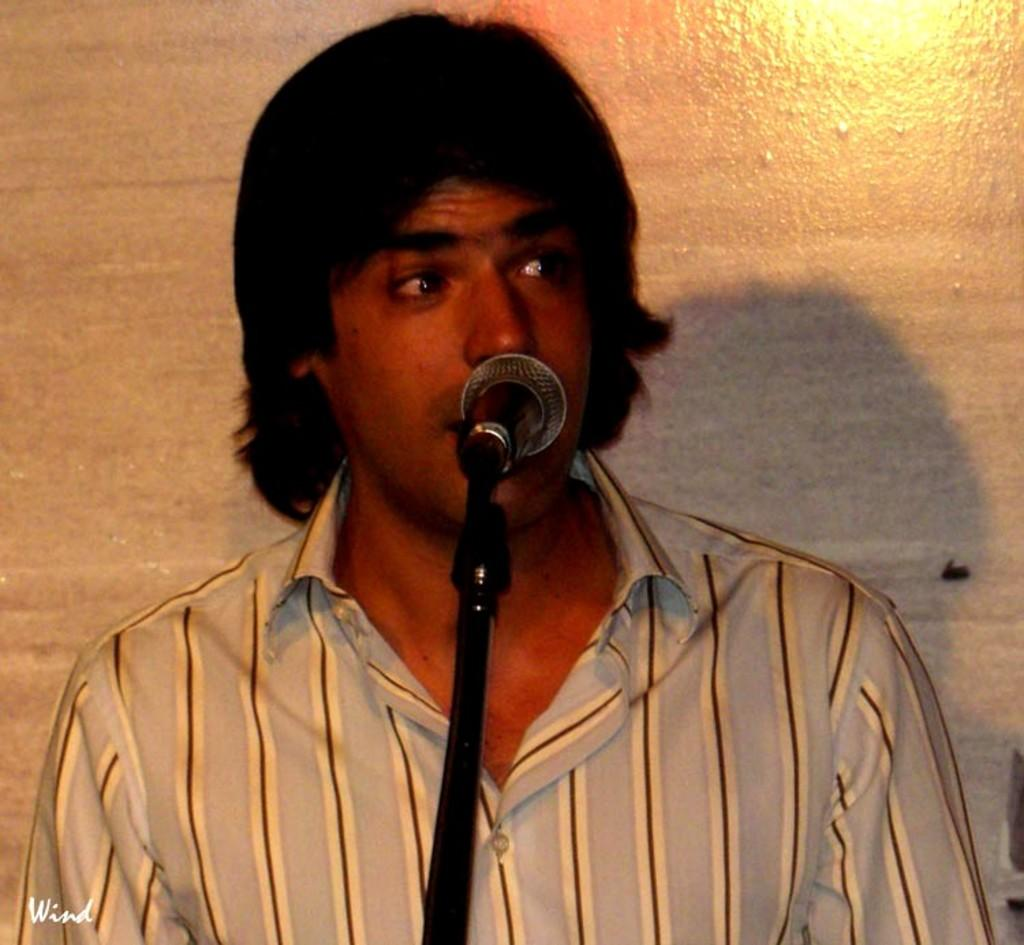What is the person in the image doing? The person in the image is riding a bicycle on the road. What type of door can be seen on the governor's office in the image? There is no governor or office present in the image; it features a person riding a bicycle on the road. 